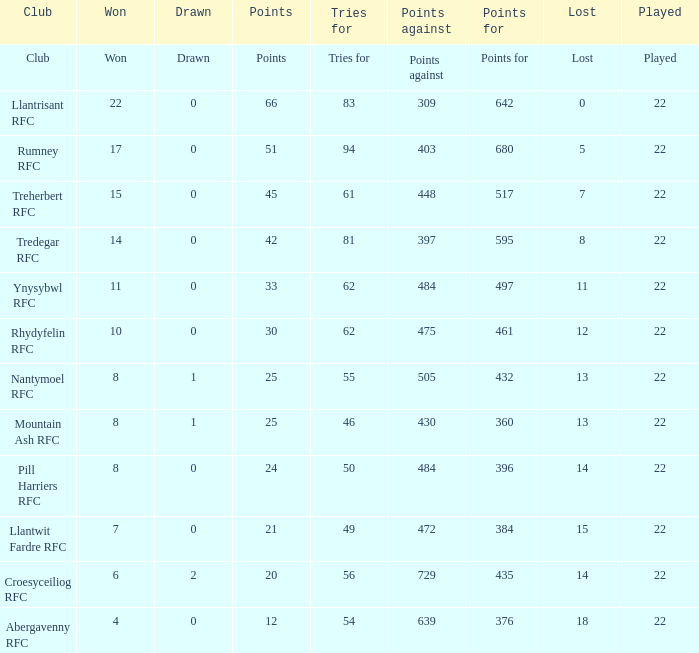For teams that won exactly 15, how many points were scored? 45.0. 